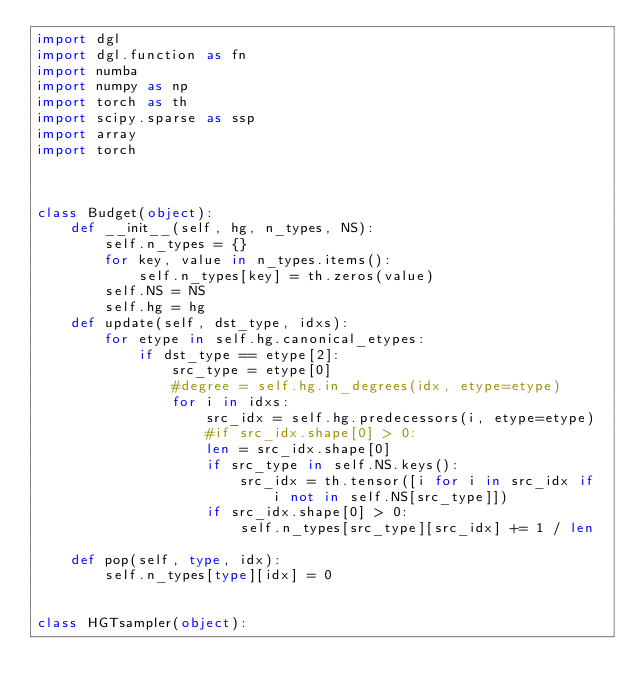<code> <loc_0><loc_0><loc_500><loc_500><_Python_>import dgl
import dgl.function as fn
import numba
import numpy as np
import torch as th
import scipy.sparse as ssp
import array
import torch



class Budget(object):
    def __init__(self, hg, n_types, NS):
        self.n_types = {}
        for key, value in n_types.items():
            self.n_types[key] = th.zeros(value)
        self.NS = NS
        self.hg = hg
    def update(self, dst_type, idxs):
        for etype in self.hg.canonical_etypes:
            if dst_type == etype[2]:
                src_type = etype[0]
                #degree = self.hg.in_degrees(idx, etype=etype)
                for i in idxs:
                    src_idx = self.hg.predecessors(i, etype=etype)
                    #if src_idx.shape[0] > 0:
                    len = src_idx.shape[0]
                    if src_type in self.NS.keys():
                        src_idx = th.tensor([i for i in src_idx if i not in self.NS[src_type]])
                    if src_idx.shape[0] > 0:
                        self.n_types[src_type][src_idx] += 1 / len

    def pop(self, type, idx):
        self.n_types[type][idx] = 0


class HGTsampler(object):</code> 